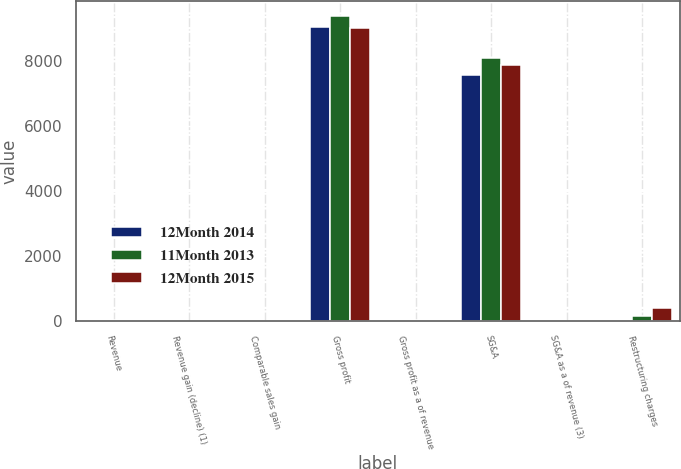Convert chart. <chart><loc_0><loc_0><loc_500><loc_500><stacked_bar_chart><ecel><fcel>Revenue<fcel>Revenue gain (decline) (1)<fcel>Comparable sales gain<fcel>Gross profit<fcel>Gross profit as a of revenue<fcel>SG&A<fcel>SG&A as a of revenue (3)<fcel>Restructuring charges<nl><fcel>12Month 2014<fcel>22.4<fcel>0.7<fcel>0.5<fcel>9047<fcel>22.4<fcel>7592<fcel>18.8<fcel>5<nl><fcel>11Month 2013<fcel>22.4<fcel>6.2<fcel>1<fcel>9399<fcel>23.1<fcel>8106<fcel>20<fcel>149<nl><fcel>12Month 2015<fcel>22.4<fcel>11.9<fcel>2.7<fcel>9023<fcel>23.6<fcel>7905<fcel>20.7<fcel>414<nl></chart> 